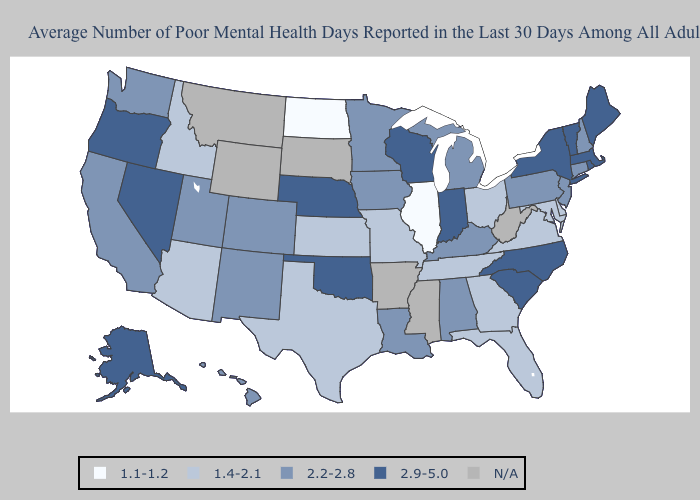What is the value of Oregon?
Write a very short answer. 2.9-5.0. Does Nevada have the highest value in the West?
Write a very short answer. Yes. Name the states that have a value in the range 2.9-5.0?
Keep it brief. Alaska, Indiana, Maine, Massachusetts, Nebraska, Nevada, New York, North Carolina, Oklahoma, Oregon, Rhode Island, South Carolina, Vermont, Wisconsin. Does the first symbol in the legend represent the smallest category?
Concise answer only. Yes. Among the states that border Colorado , which have the highest value?
Keep it brief. Nebraska, Oklahoma. What is the value of Florida?
Give a very brief answer. 1.4-2.1. What is the lowest value in the Northeast?
Keep it brief. 2.2-2.8. Name the states that have a value in the range 2.2-2.8?
Keep it brief. Alabama, California, Colorado, Connecticut, Hawaii, Iowa, Kentucky, Louisiana, Michigan, Minnesota, New Hampshire, New Jersey, New Mexico, Pennsylvania, Utah, Washington. Name the states that have a value in the range N/A?
Quick response, please. Arkansas, Mississippi, Montana, South Dakota, West Virginia, Wyoming. Among the states that border New Hampshire , which have the lowest value?
Keep it brief. Maine, Massachusetts, Vermont. Among the states that border Massachusetts , which have the highest value?
Short answer required. New York, Rhode Island, Vermont. What is the value of Georgia?
Answer briefly. 1.4-2.1. Which states have the highest value in the USA?
Give a very brief answer. Alaska, Indiana, Maine, Massachusetts, Nebraska, Nevada, New York, North Carolina, Oklahoma, Oregon, Rhode Island, South Carolina, Vermont, Wisconsin. What is the value of South Carolina?
Quick response, please. 2.9-5.0. 